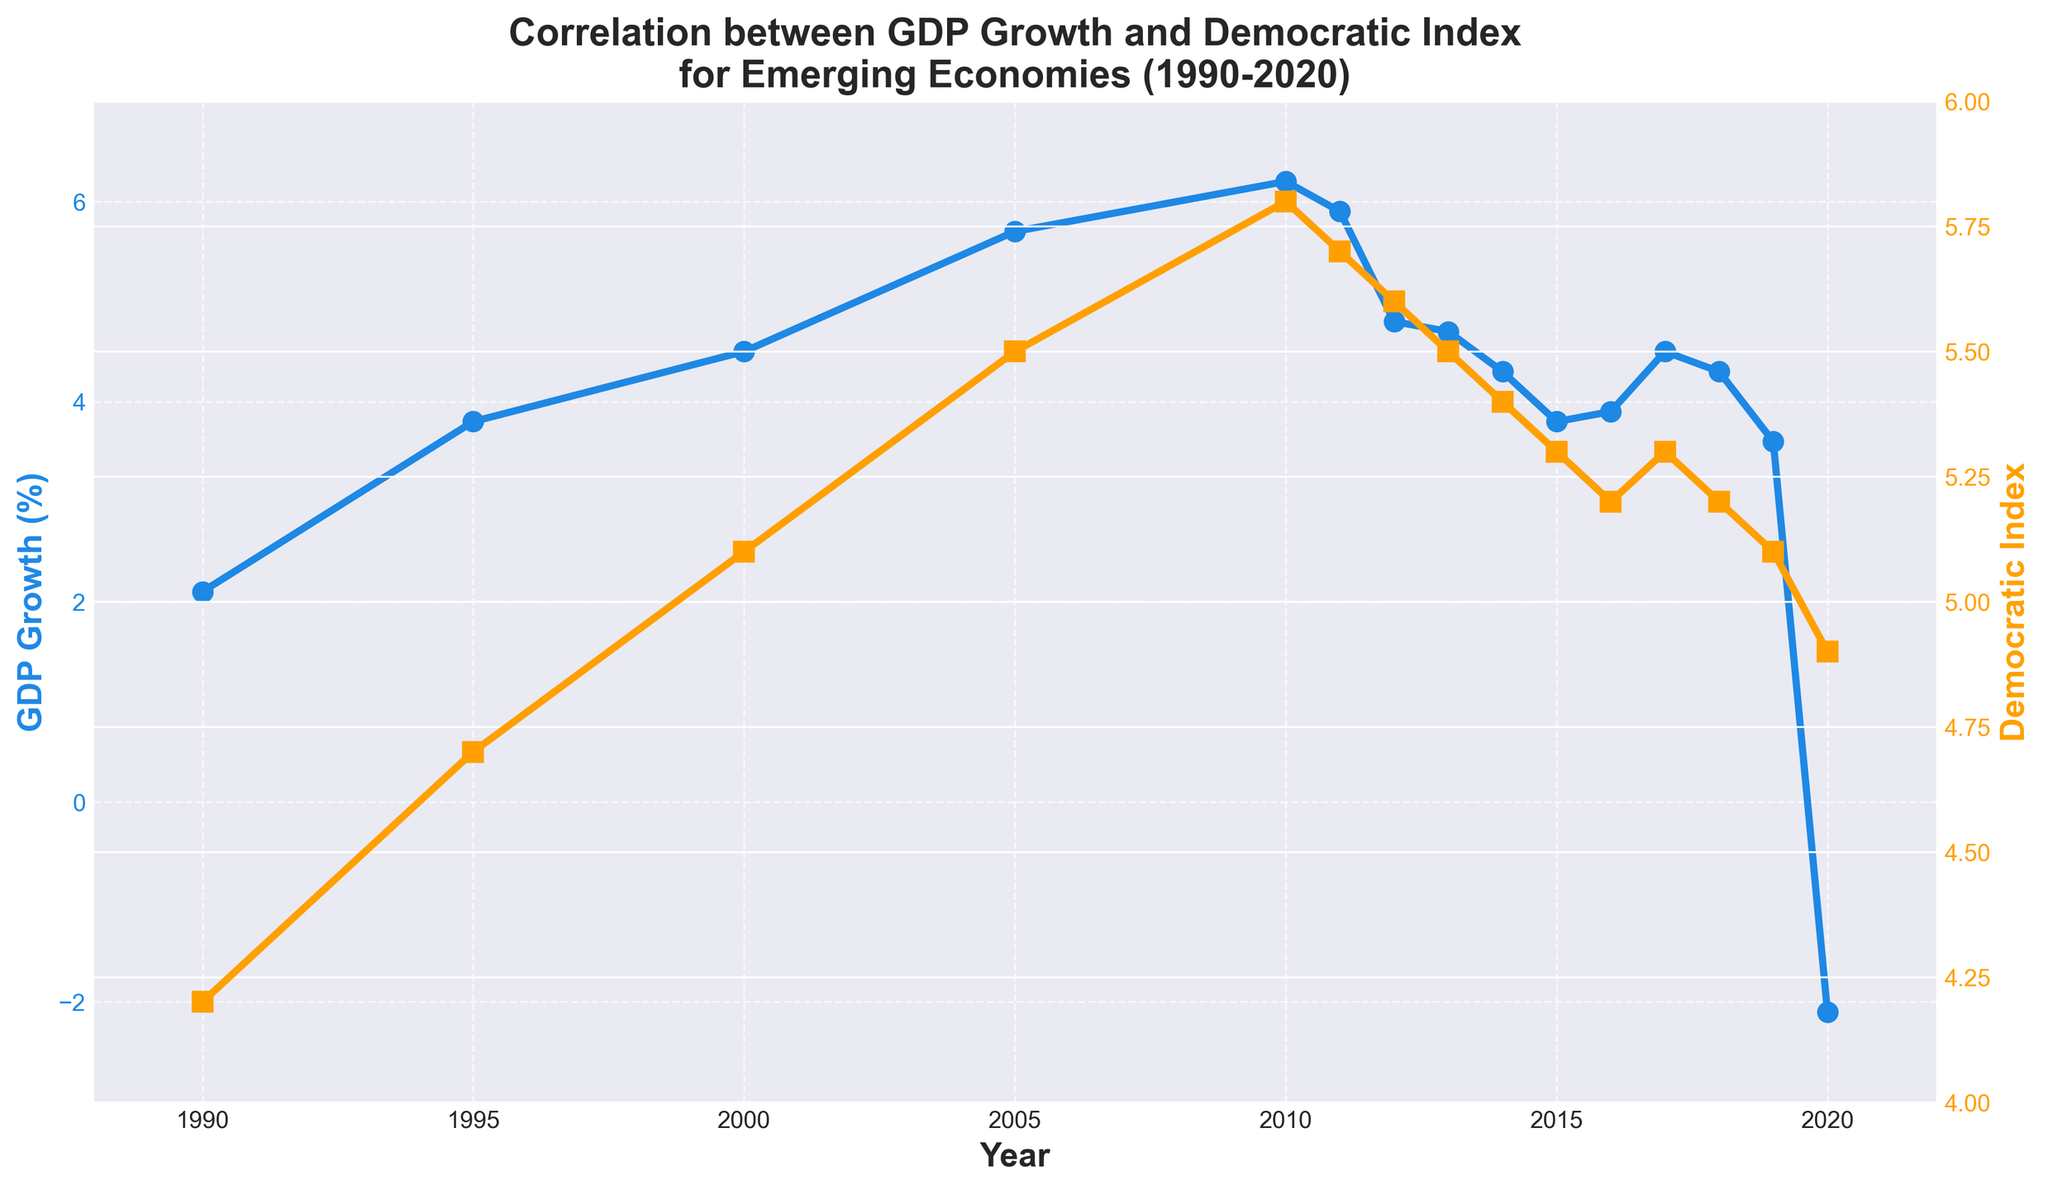What's the average GDP growth rate over the entire period? Sum the GDP growth values for each year (2.1 + 3.8 + 4.5 + 5.7 + 6.2 + 5.9 + 4.8 + 4.7 + 4.3 + 3.8 + 3.9 + 4.5 + 4.3 + 3.6 - 2.1) and divide by the number of years (15). The total sum is 60.8, so the average GDP growth is 60.8 / 15.
Answer: 4.05 In which year did the GDP growth rate peak, and what was the rate? Look at the blue line marking the GDP growth rate. The highest point on the graph is in 2010, with a rate of 6.2%.
Answer: 2010, 6.2% Which year experienced the biggest drop in GDP growth, and what was the value? Compare consecutive years to find the biggest decrease. The biggest drop is between 2019 (3.6%) and 2020 (-2.1%), which is a decrease of 5.7 percentage points.
Answer: 2020, 5.7% What is the general trend of the Democratic Index from 1990 to 2020? Observe the orange line representing the Democratic Index. It shows a general increase from 4.2 in 1990 to a peak around 2010 with smaller oscillations and a slight decline towards the end (4.9 in 2020).
Answer: Increasing initially, slight decline later Compare the Democratic Index values for 1990 and 2020. Which year had a higher value? The Democratic Index in 1990 was 4.2, whereas in 2020 it was 4.9. Thus, 2020 had a higher value.
Answer: 2020 What was the GDP growth rate in the year when the Democratic Index was highest? Identify the year when the orange line was at its highest point, which is 2010 with a value of 5.8, then refer to the blue line for the GDP growth rate (6.2%).
Answer: 6.2% How many years had a negative GDP growth rate? Identify the sections where the blue line is below the zero mark. Only 2020 had a negative GDP growth rate.
Answer: 1 During which period(s) did both GDP growth and Democratic Index move in the same direction (both increasing or both decreasing)? Review the graph to pinpoint periods where both lines (blue and orange) move with the same trend. From 1990 to 2000 both increase, and from 2013 to 2016 both decrease slightly.
Answer: 1990-2000, 2013-2016 What is the overall change in the Democratic Index from 1990 to 2020? Subtract the Democratic Index value of 1990 (4.2) from its value in 2020 (4.9). The difference is 4.9 - 4.2 = 0.7.
Answer: 0.7 How did the Democratic Index change from 2010 to 2020? Observe the values of the Democratic Index at 2010 (5.8) and 2020 (4.9). The change is 4.9 - 5.8 = -0.9, indicating a decrease of 0.9.
Answer: -0.9 